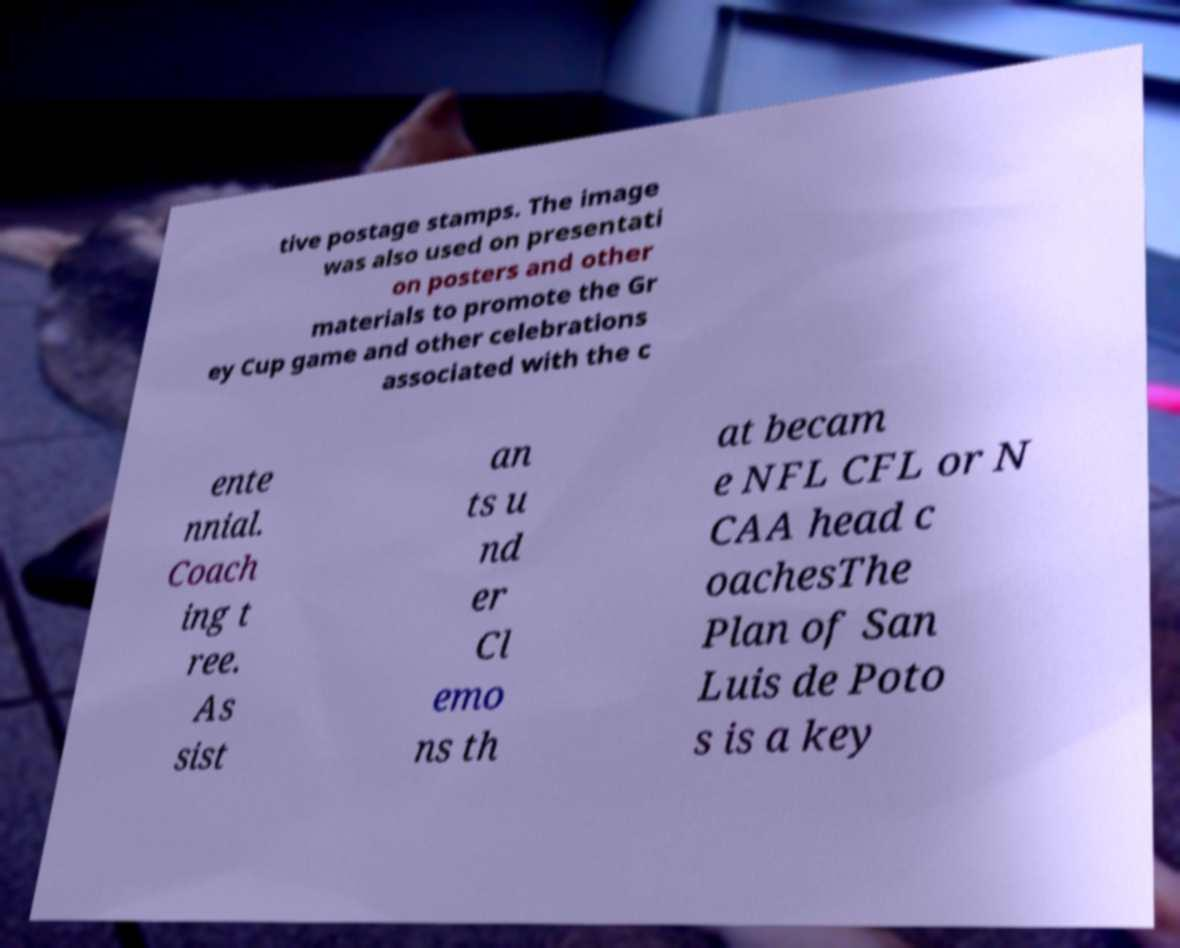Could you assist in decoding the text presented in this image and type it out clearly? tive postage stamps. The image was also used on presentati on posters and other materials to promote the Gr ey Cup game and other celebrations associated with the c ente nnial. Coach ing t ree. As sist an ts u nd er Cl emo ns th at becam e NFL CFL or N CAA head c oachesThe Plan of San Luis de Poto s is a key 